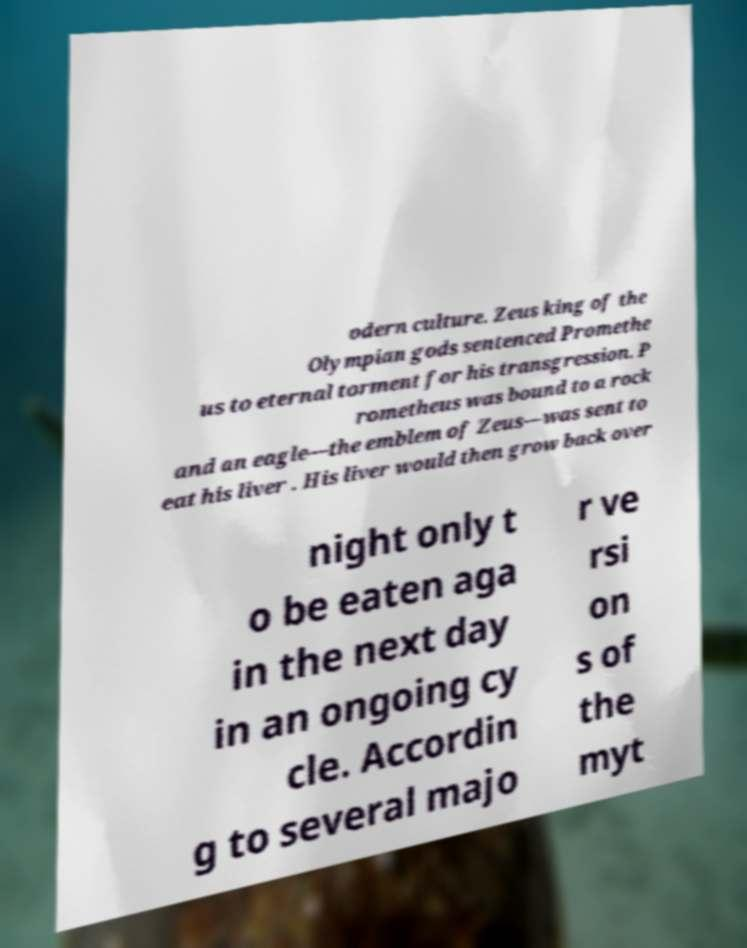Can you accurately transcribe the text from the provided image for me? odern culture. Zeus king of the Olympian gods sentenced Promethe us to eternal torment for his transgression. P rometheus was bound to a rock and an eagle—the emblem of Zeus—was sent to eat his liver . His liver would then grow back over night only t o be eaten aga in the next day in an ongoing cy cle. Accordin g to several majo r ve rsi on s of the myt 